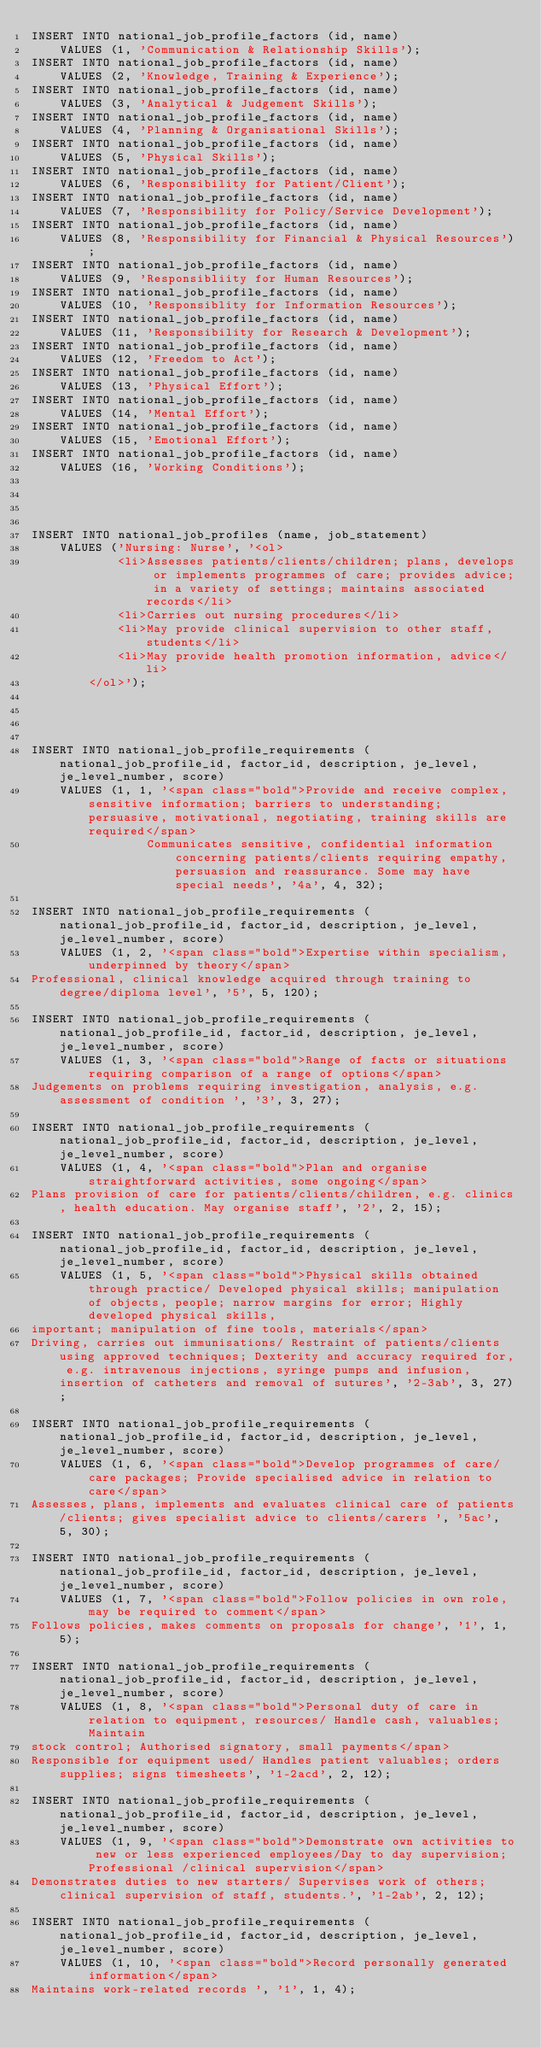Convert code to text. <code><loc_0><loc_0><loc_500><loc_500><_SQL_>INSERT INTO national_job_profile_factors (id, name)
    VALUES (1, 'Communication & Relationship Skills');
INSERT INTO national_job_profile_factors (id, name)
    VALUES (2, 'Knowledge, Training & Experience');
INSERT INTO national_job_profile_factors (id, name)
    VALUES (3, 'Analytical & Judgement Skills');
INSERT INTO national_job_profile_factors (id, name)
    VALUES (4, 'Planning & Organisational Skills');
INSERT INTO national_job_profile_factors (id, name)
    VALUES (5, 'Physical Skills');
INSERT INTO national_job_profile_factors (id, name)
    VALUES (6, 'Responsibility for Patient/Client');
INSERT INTO national_job_profile_factors (id, name)
    VALUES (7, 'Responsibility for Policy/Service Development');
INSERT INTO national_job_profile_factors (id, name)
    VALUES (8, 'Responsibility for Financial & Physical Resources');
INSERT INTO national_job_profile_factors (id, name)
    VALUES (9, 'Responsibliity for Human Resources');
INSERT INTO national_job_profile_factors (id, name)
    VALUES (10, 'Responsiblity for Information Resources');
INSERT INTO national_job_profile_factors (id, name)
    VALUES (11, 'Responsibility for Research & Development');
INSERT INTO national_job_profile_factors (id, name)
    VALUES (12, 'Freedom to Act');
INSERT INTO national_job_profile_factors (id, name)
    VALUES (13, 'Physical Effort');
INSERT INTO national_job_profile_factors (id, name)
    VALUES (14, 'Mental Effort');
INSERT INTO national_job_profile_factors (id, name)
    VALUES (15, 'Emotional Effort');
INSERT INTO national_job_profile_factors (id, name)
    VALUES (16, 'Working Conditions');




INSERT INTO national_job_profiles (name, job_statement)
    VALUES ('Nursing: Nurse', '<ol>
            <li>Assesses patients/clients/children; plans, develops or implements programmes of care; provides advice; in a variety of settings; maintains associated records</li>
            <li>Carries out nursing procedures</li>
            <li>May provide clinical supervision to other staff, students</li>
            <li>May provide health promotion information, advice</li>
        </ol>');




INSERT INTO national_job_profile_requirements (national_job_profile_id, factor_id, description, je_level, je_level_number, score)
    VALUES (1, 1, '<span class="bold">Provide and receive complex, sensitive information; barriers to understanding; persuasive, motivational, negotiating, training skills are required</span>
                Communicates sensitive, confidential information concerning patients/clients requiring empathy, persuasion and reassurance. Some may have special needs', '4a', 4, 32);

INSERT INTO national_job_profile_requirements (national_job_profile_id, factor_id, description, je_level, je_level_number, score)
    VALUES (1, 2, '<span class="bold">Expertise within specialism, underpinned by theory</span>
Professional, clinical knowledge acquired through training to degree/diploma level', '5', 5, 120);

INSERT INTO national_job_profile_requirements (national_job_profile_id, factor_id, description, je_level, je_level_number, score)
    VALUES (1, 3, '<span class="bold">Range of facts or situations requiring comparison of a range of options</span>
Judgements on problems requiring investigation, analysis, e.g. assessment of condition ', '3', 3, 27);

INSERT INTO national_job_profile_requirements (national_job_profile_id, factor_id, description, je_level, je_level_number, score)
    VALUES (1, 4, '<span class="bold">Plan and organise straightforward activities, some ongoing</span>
Plans provision of care for patients/clients/children, e.g. clinics, health education. May organise staff', '2', 2, 15);

INSERT INTO national_job_profile_requirements (national_job_profile_id, factor_id, description, je_level, je_level_number, score)
    VALUES (1, 5, '<span class="bold">Physical skills obtained through practice/ Developed physical skills; manipulation of objects, people; narrow margins for error; Highly developed physical skills, 
important; manipulation of fine tools, materials</span>
Driving, carries out immunisations/ Restraint of patients/clients using approved techniques; Dexterity and accuracy required for, e.g. intravenous injections, syringe pumps and infusion, insertion of catheters and removal of sutures', '2-3ab', 3, 27);

INSERT INTO national_job_profile_requirements (national_job_profile_id, factor_id, description, je_level, je_level_number, score)
    VALUES (1, 6, '<span class="bold">Develop programmes of care/care packages; Provide specialised advice in relation to care</span>
Assesses, plans, implements and evaluates clinical care of patients/clients; gives specialist advice to clients/carers ', '5ac', 5, 30);

INSERT INTO national_job_profile_requirements (national_job_profile_id, factor_id, description, je_level, je_level_number, score)
    VALUES (1, 7, '<span class="bold">Follow policies in own role, may be required to comment</span>
Follows policies, makes comments on proposals for change', '1', 1, 5);

INSERT INTO national_job_profile_requirements (national_job_profile_id, factor_id, description, je_level, je_level_number, score)
    VALUES (1, 8, '<span class="bold">Personal duty of care in relation to equipment, resources/ Handle cash, valuables; Maintain
stock control; Authorised signatory, small payments</span>
Responsible for equipment used/ Handles patient valuables; orders supplies; signs timesheets', '1-2acd', 2, 12);

INSERT INTO national_job_profile_requirements (national_job_profile_id, factor_id, description, je_level, je_level_number, score)
    VALUES (1, 9, '<span class="bold">Demonstrate own activities to new or less experienced employees/Day to day supervision; Professional /clinical supervision</span>
Demonstrates duties to new starters/ Supervises work of others; clinical supervision of staff, students.', '1-2ab', 2, 12);

INSERT INTO national_job_profile_requirements (national_job_profile_id, factor_id, description, je_level, je_level_number, score)
    VALUES (1, 10, '<span class="bold">Record personally generated information</span>
Maintains work-related records ', '1', 1, 4);
</code> 